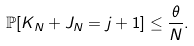Convert formula to latex. <formula><loc_0><loc_0><loc_500><loc_500>\mathbb { P } [ K _ { N } + J _ { N } = j + 1 ] \leq \frac { \theta } { N } .</formula> 